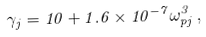<formula> <loc_0><loc_0><loc_500><loc_500>\gamma _ { j } = 1 0 + 1 . 6 \times 1 0 ^ { - 7 } \omega _ { p j } ^ { 3 } \, ,</formula> 